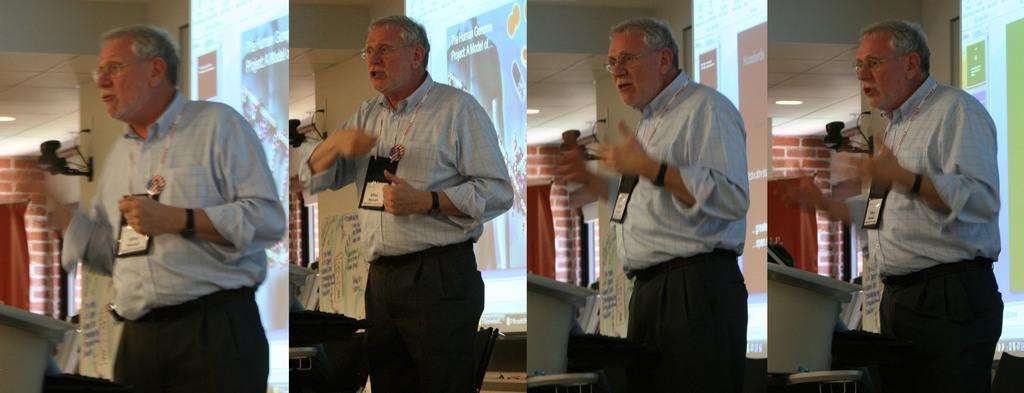Who or what is present in the image? There is a person in the image. What is the person wearing in the image? The person is wearing an ID card. Can you tell me how many bombs are present in the image? There are no bombs present in the image; it only features a person wearing an ID card. How does the person's ID card compare to another ID card in the image? There is no other ID card present in the image for comparison. 